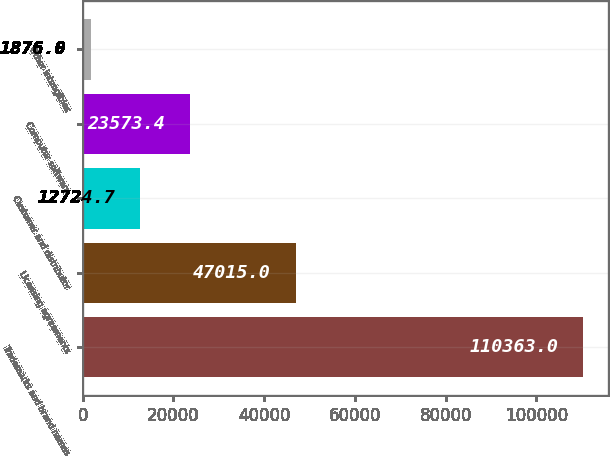<chart> <loc_0><loc_0><loc_500><loc_500><bar_chart><fcel>Trademarks and brand names<fcel>Licensing agreements<fcel>Customer and distributor<fcel>Computer software<fcel>Other intangibles<nl><fcel>110363<fcel>47015<fcel>12724.7<fcel>23573.4<fcel>1876<nl></chart> 